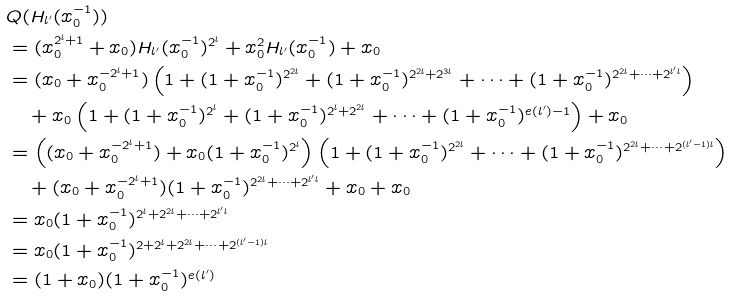Convert formula to latex. <formula><loc_0><loc_0><loc_500><loc_500>& Q ( H _ { l ^ { \prime } } ( x _ { 0 } ^ { - 1 } ) ) \\ & = ( x _ { 0 } ^ { 2 ^ { l } + 1 } + x _ { 0 } ) H _ { l ^ { \prime } } ( x _ { 0 } ^ { - 1 } ) ^ { 2 ^ { l } } + x _ { 0 } ^ { 2 } H _ { l ^ { \prime } } ( x _ { 0 } ^ { - 1 } ) + x _ { 0 } \\ & = ( x _ { 0 } + x _ { 0 } ^ { - 2 ^ { l } + 1 } ) \left ( 1 + ( 1 + x _ { 0 } ^ { - 1 } ) ^ { 2 ^ { 2 l } } + ( 1 + x _ { 0 } ^ { - 1 } ) ^ { 2 ^ { 2 l } + 2 ^ { 3 l } } + \cdots + ( 1 + x _ { 0 } ^ { - 1 } ) ^ { 2 ^ { 2 l } + \cdots + 2 ^ { l ^ { \prime } l } } \right ) \\ & \quad + x _ { 0 } \left ( 1 + ( 1 + x _ { 0 } ^ { - 1 } ) ^ { 2 ^ { l } } + ( 1 + x _ { 0 } ^ { - 1 } ) ^ { 2 ^ { l } + 2 ^ { 2 l } } + \cdots + ( 1 + x _ { 0 } ^ { - 1 } ) ^ { e ( l ^ { \prime } ) - 1 } \right ) + x _ { 0 } \\ & = \left ( ( x _ { 0 } + x _ { 0 } ^ { - 2 ^ { l } + 1 } ) + x _ { 0 } ( 1 + x _ { 0 } ^ { - 1 } ) ^ { 2 ^ { l } } \right ) \left ( 1 + ( 1 + x _ { 0 } ^ { - 1 } ) ^ { 2 ^ { 2 l } } + \cdots + ( 1 + x _ { 0 } ^ { - 1 } ) ^ { 2 ^ { 2 l } + \cdots + 2 ^ { ( l ^ { \prime } - 1 ) l } } \right ) \\ & \quad + ( x _ { 0 } + x _ { 0 } ^ { - 2 ^ { l } + 1 } ) ( 1 + x _ { 0 } ^ { - 1 } ) ^ { 2 ^ { 2 l } + \cdots + 2 ^ { l ^ { \prime } l } } + x _ { 0 } + x _ { 0 } \\ & = x _ { 0 } ( 1 + x _ { 0 } ^ { - 1 } ) ^ { 2 ^ { l } + 2 ^ { 2 l } + \cdots + 2 ^ { l ^ { \prime } l } } \\ & = x _ { 0 } ( 1 + x _ { 0 } ^ { - 1 } ) ^ { 2 + 2 ^ { l } + 2 ^ { 2 l } + \cdots + 2 ^ { ( l ^ { \prime } - 1 ) l } } \\ & = ( 1 + x _ { 0 } ) ( 1 + x _ { 0 } ^ { - 1 } ) ^ { e ( l ^ { \prime } ) }</formula> 